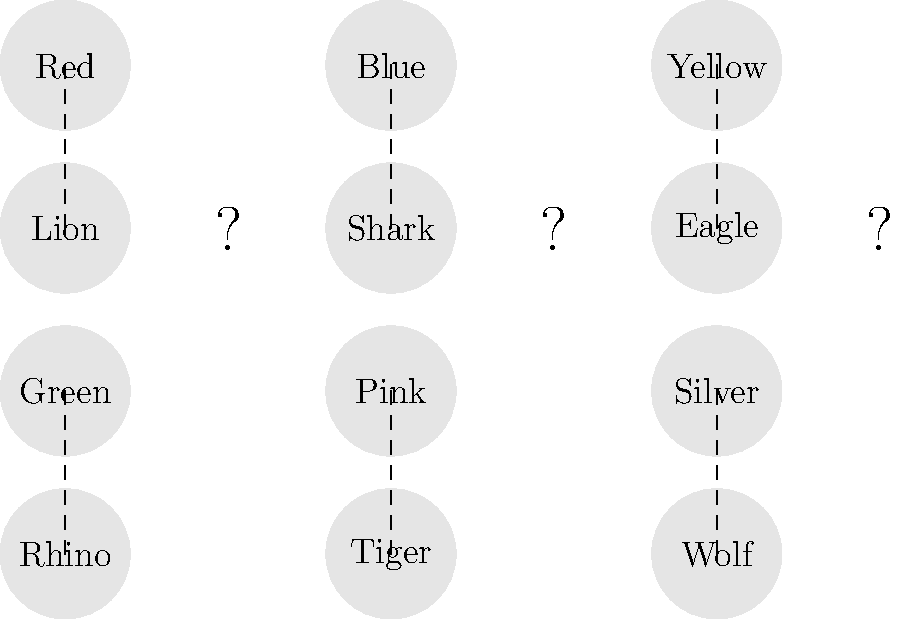In this classic Sentai team lineup, match the remaining Rangers to their corresponding mecha components. Which mecha belongs to the Yellow Ranger? To solve this puzzle, let's follow these steps:

1. Observe that we have six Rangers: Red, Blue, Yellow, Green, Pink, and Silver.
2. We also have six mecha components: Lion, Shark, Eagle, Rhino, Tiger, and Wolf.
3. Three connections are already made:
   - Red is connected to Lion
   - Green is connected to Rhino
   - Pink is connected to Tiger
4. This leaves us with Blue, Yellow, and Silver Rangers to match.
5. The remaining mecha are Shark, Eagle, and Wolf.
6. In many Sentai series, color schemes and animal themes often correlate:
   - Blue is often associated with water, so it's likely paired with the Shark.
   - Silver, being a metallic color, is often associated with canine or wolf themes.
7. By process of elimination, this leaves the Eagle for the Yellow Ranger.

This matching follows common Sentai tropes where aerial mecha are often assigned to Yellow Rangers, representing the sky or air element in the team's theme.
Answer: Eagle 